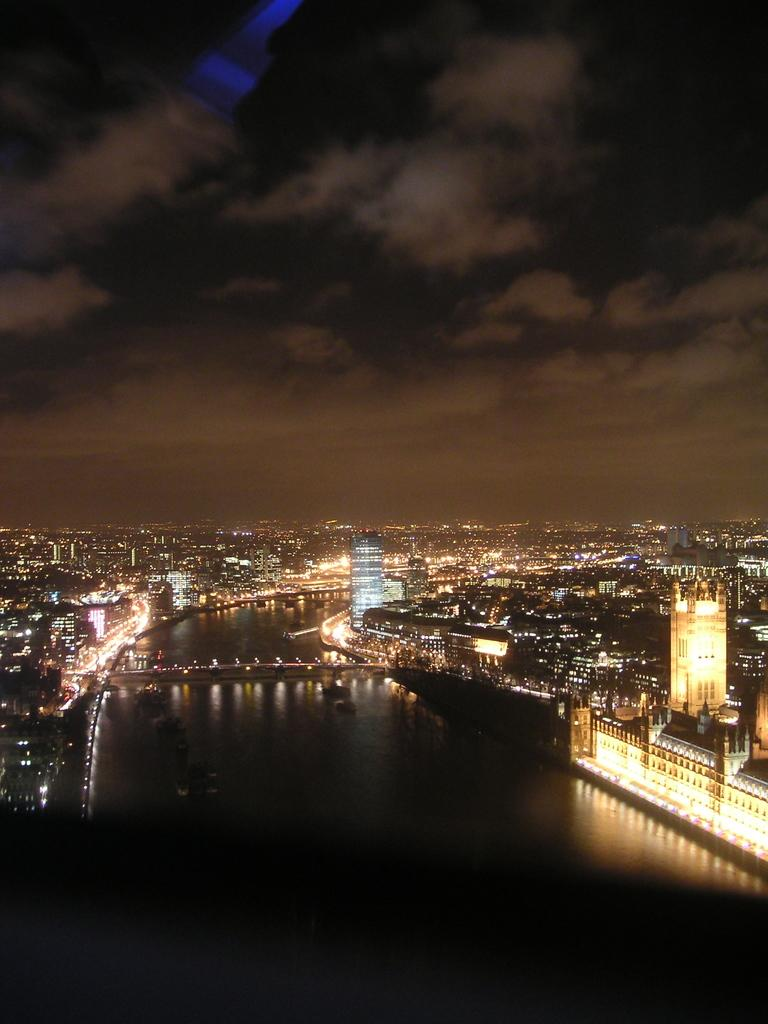What type of location is depicted in the image? There is a city in the image. What natural element can be seen in the image? There is water visible in the image. What structure connects the two sides of the water? There is a bridge in the image. What type of structures are present on either side of the bridge? There are buildings on either side of the bridge. What type of scissors can be seen cutting through the waves in the image? There are no scissors or waves present in the image. What type of gate can be seen at the entrance of the city in the image? There is no gate visible in the image; the focus is on the bridge and the buildings. 